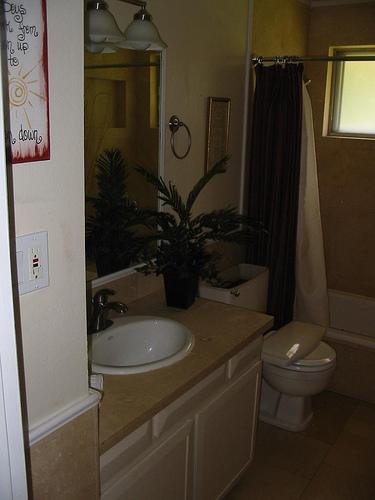How many plants are on the sink?
Short answer required. 1. Is the window open?
Be succinct. No. Are there towels under the sink?
Keep it brief. No. Is the light on?
Be succinct. No. What is the plant sitting on?
Keep it brief. Counter. How many sinks are in the bathroom?
Quick response, please. 1. What color is the countertop?
Concise answer only. Tan. What shape is the mirror?
Quick response, please. Square. Does this bathtub have a shower curtain?
Quick response, please. Yes. What is the black item?
Concise answer only. Curtain. What is hanging on the wall?
Concise answer only. Picture. Is the bathtub shallow?
Be succinct. Yes. What color is the sink bowl?
Concise answer only. White. Has the lid of the toilet tank been moved from its usual place?
Quick response, please. Yes. What is the counter made of?
Short answer required. Granite. Is the sink made of glass?
Concise answer only. No. Is the shower curtain open or closed?
Short answer required. Open. 